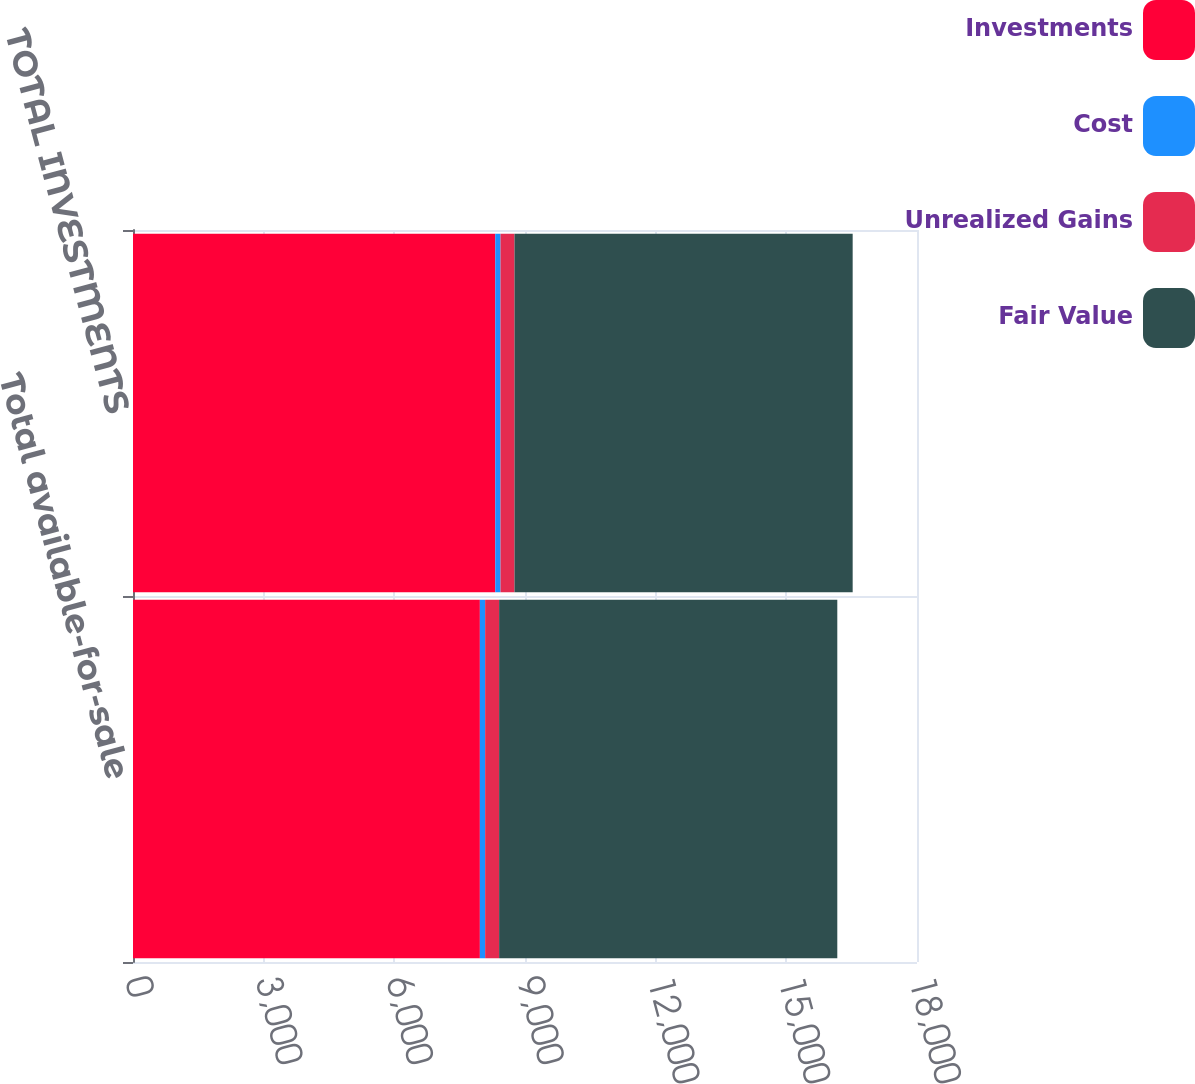Convert chart. <chart><loc_0><loc_0><loc_500><loc_500><stacked_bar_chart><ecel><fcel>Total available-for-sale<fcel>TOTAL INVESTMENTS<nl><fcel>Investments<fcel>7964<fcel>8317<nl><fcel>Cost<fcel>121<fcel>121<nl><fcel>Unrealized Gains<fcel>321<fcel>321<nl><fcel>Fair Value<fcel>7764<fcel>7764<nl></chart> 